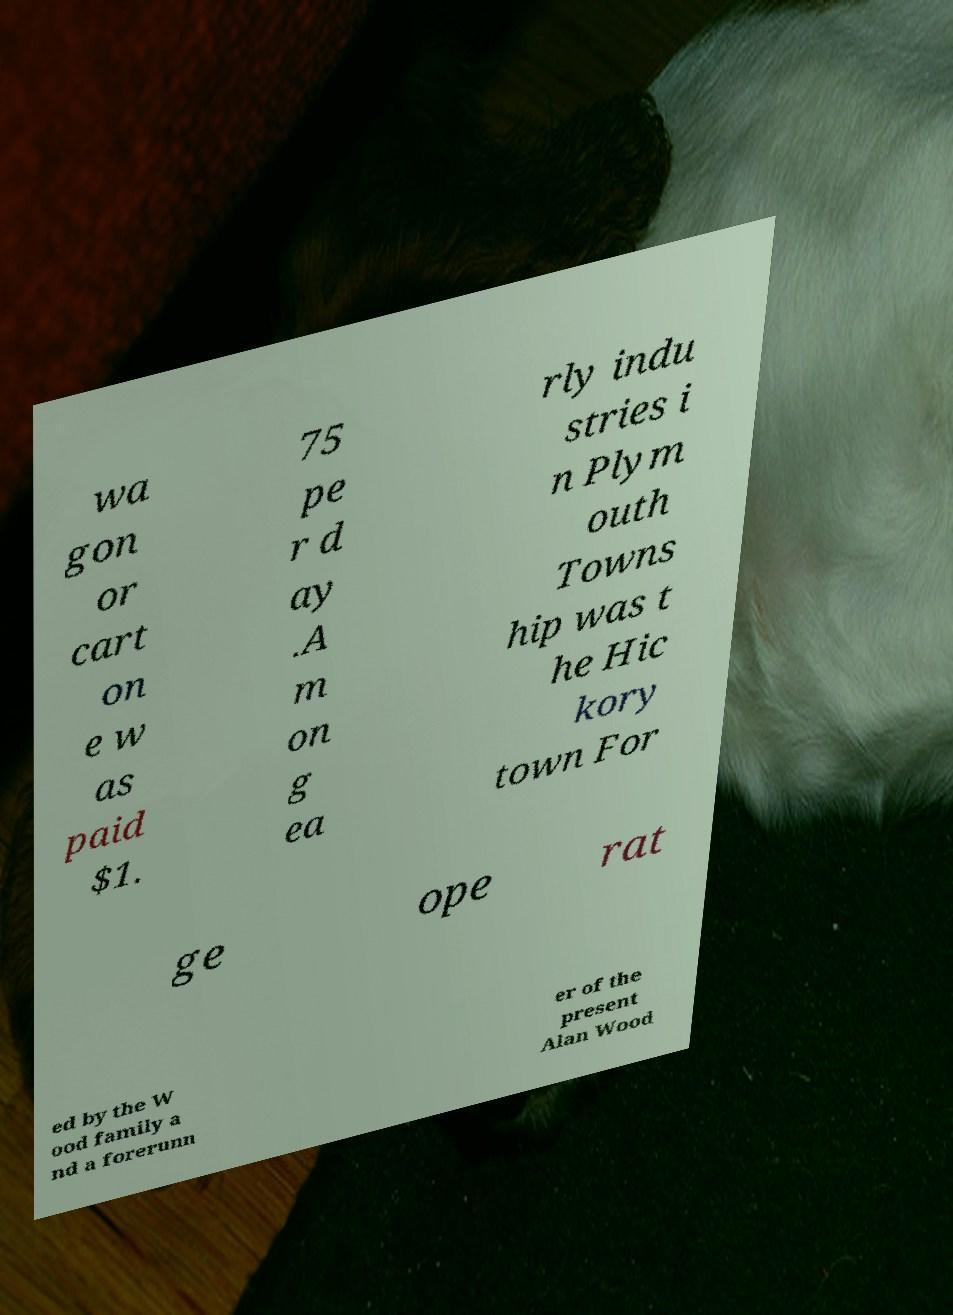Can you read and provide the text displayed in the image?This photo seems to have some interesting text. Can you extract and type it out for me? wa gon or cart on e w as paid $1. 75 pe r d ay .A m on g ea rly indu stries i n Plym outh Towns hip was t he Hic kory town For ge ope rat ed by the W ood family a nd a forerunn er of the present Alan Wood 